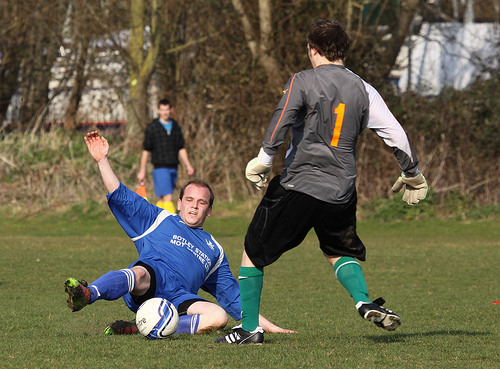<image>
Can you confirm if the tree is behind the ball? Yes. From this viewpoint, the tree is positioned behind the ball, with the ball partially or fully occluding the tree. Where is the tree in relation to the ball? Is it above the ball? No. The tree is not positioned above the ball. The vertical arrangement shows a different relationship. 